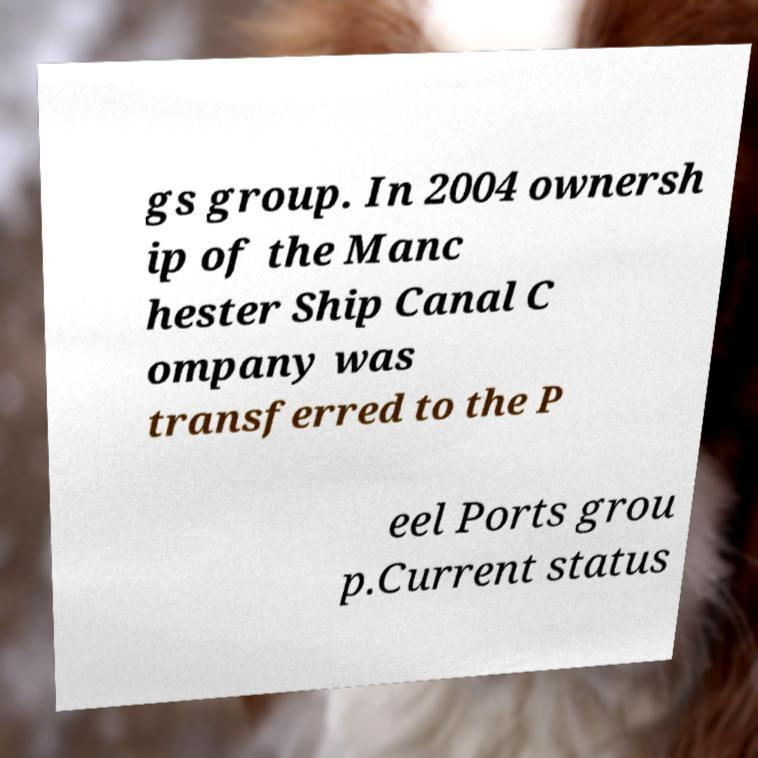I need the written content from this picture converted into text. Can you do that? gs group. In 2004 ownersh ip of the Manc hester Ship Canal C ompany was transferred to the P eel Ports grou p.Current status 